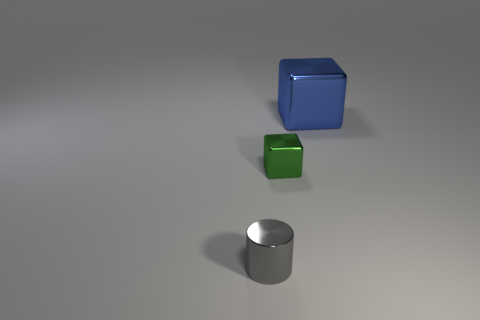There is a small thing that is made of the same material as the small cylinder; what is its shape?
Provide a short and direct response. Cube. Is the number of metal blocks that are in front of the green shiny cube less than the number of purple metal objects?
Your response must be concise. No. Do the green thing and the big blue thing have the same shape?
Your response must be concise. Yes. How many rubber things are either blue things or gray things?
Keep it short and to the point. 0. Is there a green metallic object of the same size as the blue shiny object?
Keep it short and to the point. No. What number of blue blocks have the same size as the blue metal object?
Your answer should be very brief. 0. Is the size of the metallic block on the left side of the large blue metal cube the same as the shiny object that is behind the tiny shiny cube?
Ensure brevity in your answer.  No. How many objects are either metallic cubes or shiny things in front of the blue metallic cube?
Your response must be concise. 3. What color is the large metal cube?
Offer a very short reply. Blue. There is a tiny object that is behind the small gray metal object that is on the left side of the small object to the right of the cylinder; what is its material?
Offer a terse response. Metal. 